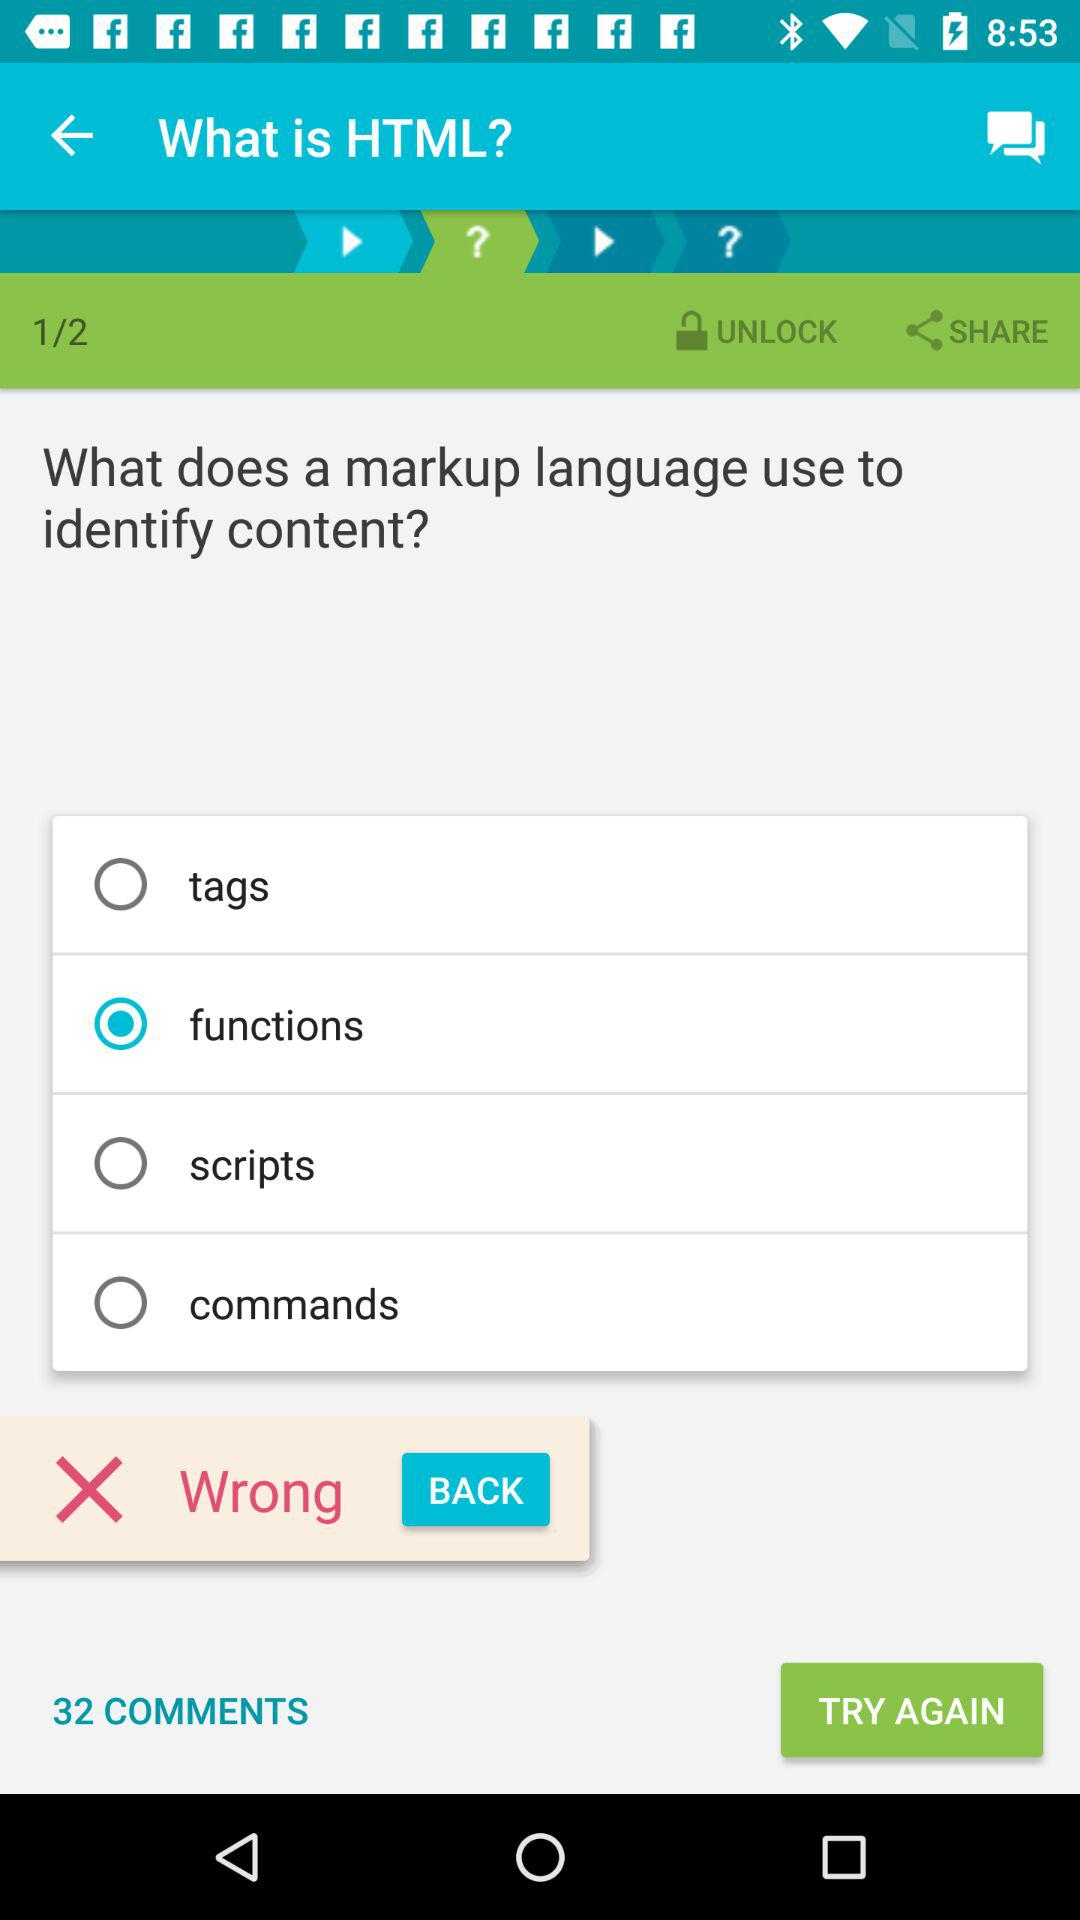How many pages in total are there? There are 2 pages in total. 